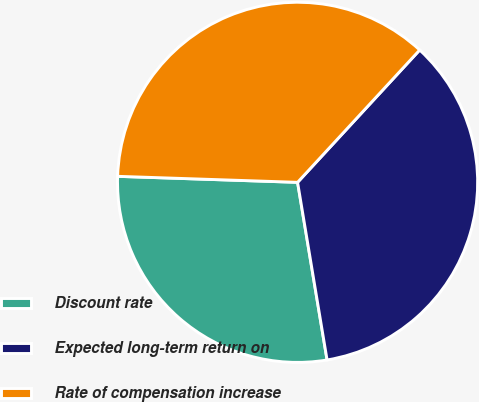<chart> <loc_0><loc_0><loc_500><loc_500><pie_chart><fcel>Discount rate<fcel>Expected long-term return on<fcel>Rate of compensation increase<nl><fcel>28.15%<fcel>35.52%<fcel>36.33%<nl></chart> 